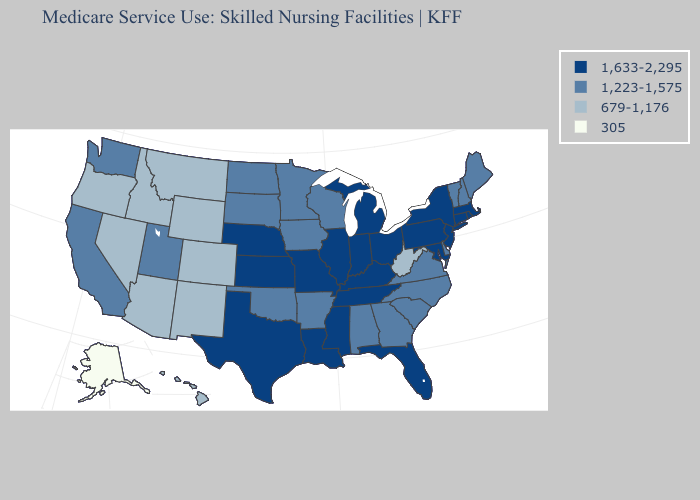Among the states that border Arkansas , does Oklahoma have the lowest value?
Concise answer only. Yes. Does Arkansas have the lowest value in the USA?
Write a very short answer. No. What is the highest value in states that border Oregon?
Answer briefly. 1,223-1,575. What is the value of California?
Short answer required. 1,223-1,575. What is the highest value in the USA?
Answer briefly. 1,633-2,295. What is the lowest value in the South?
Answer briefly. 679-1,176. Which states have the lowest value in the USA?
Concise answer only. Alaska. Among the states that border New Hampshire , which have the highest value?
Keep it brief. Massachusetts. Which states have the lowest value in the MidWest?
Be succinct. Iowa, Minnesota, North Dakota, South Dakota, Wisconsin. Name the states that have a value in the range 679-1,176?
Keep it brief. Arizona, Colorado, Hawaii, Idaho, Montana, Nevada, New Mexico, Oregon, West Virginia, Wyoming. Name the states that have a value in the range 1,633-2,295?
Answer briefly. Connecticut, Florida, Illinois, Indiana, Kansas, Kentucky, Louisiana, Maryland, Massachusetts, Michigan, Mississippi, Missouri, Nebraska, New Jersey, New York, Ohio, Pennsylvania, Rhode Island, Tennessee, Texas. Does the map have missing data?
Quick response, please. No. Does Nevada have the highest value in the West?
Write a very short answer. No. What is the value of Tennessee?
Short answer required. 1,633-2,295. Among the states that border Texas , which have the lowest value?
Give a very brief answer. New Mexico. 